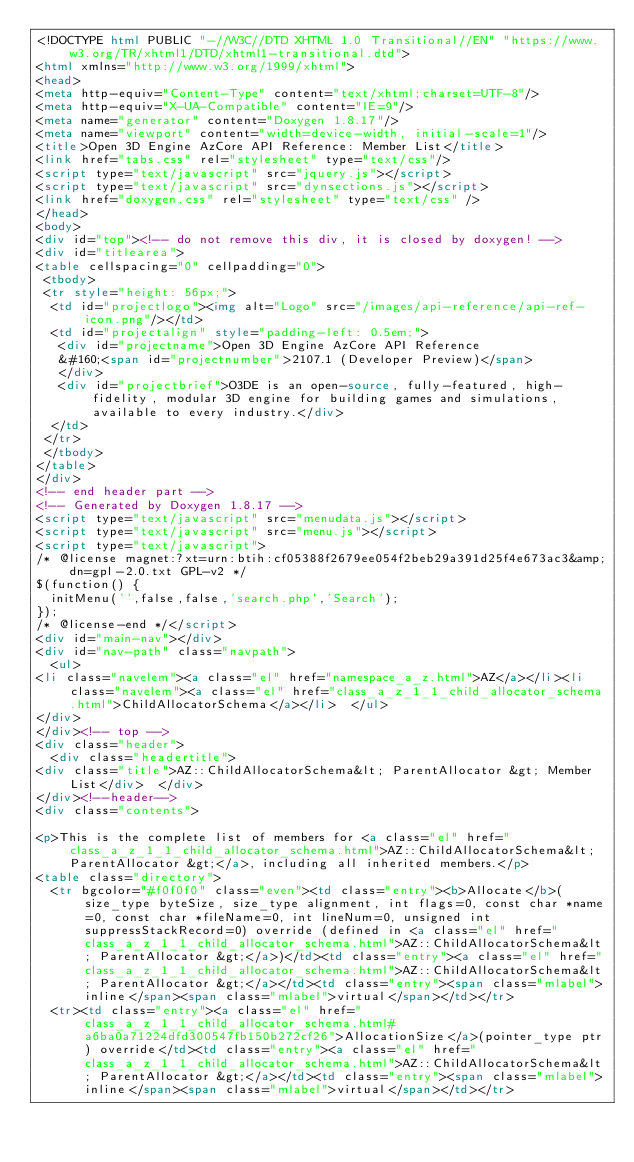Convert code to text. <code><loc_0><loc_0><loc_500><loc_500><_HTML_><!DOCTYPE html PUBLIC "-//W3C//DTD XHTML 1.0 Transitional//EN" "https://www.w3.org/TR/xhtml1/DTD/xhtml1-transitional.dtd">
<html xmlns="http://www.w3.org/1999/xhtml">
<head>
<meta http-equiv="Content-Type" content="text/xhtml;charset=UTF-8"/>
<meta http-equiv="X-UA-Compatible" content="IE=9"/>
<meta name="generator" content="Doxygen 1.8.17"/>
<meta name="viewport" content="width=device-width, initial-scale=1"/>
<title>Open 3D Engine AzCore API Reference: Member List</title>
<link href="tabs.css" rel="stylesheet" type="text/css"/>
<script type="text/javascript" src="jquery.js"></script>
<script type="text/javascript" src="dynsections.js"></script>
<link href="doxygen.css" rel="stylesheet" type="text/css" />
</head>
<body>
<div id="top"><!-- do not remove this div, it is closed by doxygen! -->
<div id="titlearea">
<table cellspacing="0" cellpadding="0">
 <tbody>
 <tr style="height: 56px;">
  <td id="projectlogo"><img alt="Logo" src="/images/api-reference/api-ref-icon.png"/></td>
  <td id="projectalign" style="padding-left: 0.5em;">
   <div id="projectname">Open 3D Engine AzCore API Reference
   &#160;<span id="projectnumber">2107.1 (Developer Preview)</span>
   </div>
   <div id="projectbrief">O3DE is an open-source, fully-featured, high-fidelity, modular 3D engine for building games and simulations, available to every industry.</div>
  </td>
 </tr>
 </tbody>
</table>
</div>
<!-- end header part -->
<!-- Generated by Doxygen 1.8.17 -->
<script type="text/javascript" src="menudata.js"></script>
<script type="text/javascript" src="menu.js"></script>
<script type="text/javascript">
/* @license magnet:?xt=urn:btih:cf05388f2679ee054f2beb29a391d25f4e673ac3&amp;dn=gpl-2.0.txt GPL-v2 */
$(function() {
  initMenu('',false,false,'search.php','Search');
});
/* @license-end */</script>
<div id="main-nav"></div>
<div id="nav-path" class="navpath">
  <ul>
<li class="navelem"><a class="el" href="namespace_a_z.html">AZ</a></li><li class="navelem"><a class="el" href="class_a_z_1_1_child_allocator_schema.html">ChildAllocatorSchema</a></li>  </ul>
</div>
</div><!-- top -->
<div class="header">
  <div class="headertitle">
<div class="title">AZ::ChildAllocatorSchema&lt; ParentAllocator &gt; Member List</div>  </div>
</div><!--header-->
<div class="contents">

<p>This is the complete list of members for <a class="el" href="class_a_z_1_1_child_allocator_schema.html">AZ::ChildAllocatorSchema&lt; ParentAllocator &gt;</a>, including all inherited members.</p>
<table class="directory">
  <tr bgcolor="#f0f0f0" class="even"><td class="entry"><b>Allocate</b>(size_type byteSize, size_type alignment, int flags=0, const char *name=0, const char *fileName=0, int lineNum=0, unsigned int suppressStackRecord=0) override (defined in <a class="el" href="class_a_z_1_1_child_allocator_schema.html">AZ::ChildAllocatorSchema&lt; ParentAllocator &gt;</a>)</td><td class="entry"><a class="el" href="class_a_z_1_1_child_allocator_schema.html">AZ::ChildAllocatorSchema&lt; ParentAllocator &gt;</a></td><td class="entry"><span class="mlabel">inline</span><span class="mlabel">virtual</span></td></tr>
  <tr><td class="entry"><a class="el" href="class_a_z_1_1_child_allocator_schema.html#a6ba0a71224dfd300547fb150b272cf26">AllocationSize</a>(pointer_type ptr) override</td><td class="entry"><a class="el" href="class_a_z_1_1_child_allocator_schema.html">AZ::ChildAllocatorSchema&lt; ParentAllocator &gt;</a></td><td class="entry"><span class="mlabel">inline</span><span class="mlabel">virtual</span></td></tr></code> 